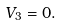Convert formula to latex. <formula><loc_0><loc_0><loc_500><loc_500>V _ { 3 } = 0 .</formula> 